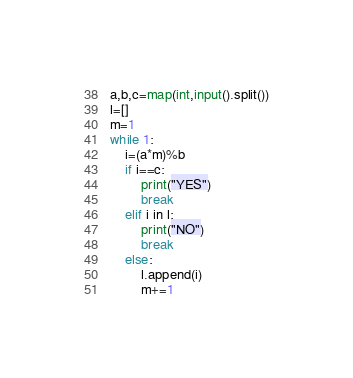<code> <loc_0><loc_0><loc_500><loc_500><_Python_>a,b,c=map(int,input().split())
l=[]
m=1
while 1:
    i=(a*m)%b
    if i==c:
        print("YES")
        break
    elif i in l:
        print("NO")
        break
    else:
        l.append(i)
        m+=1</code> 